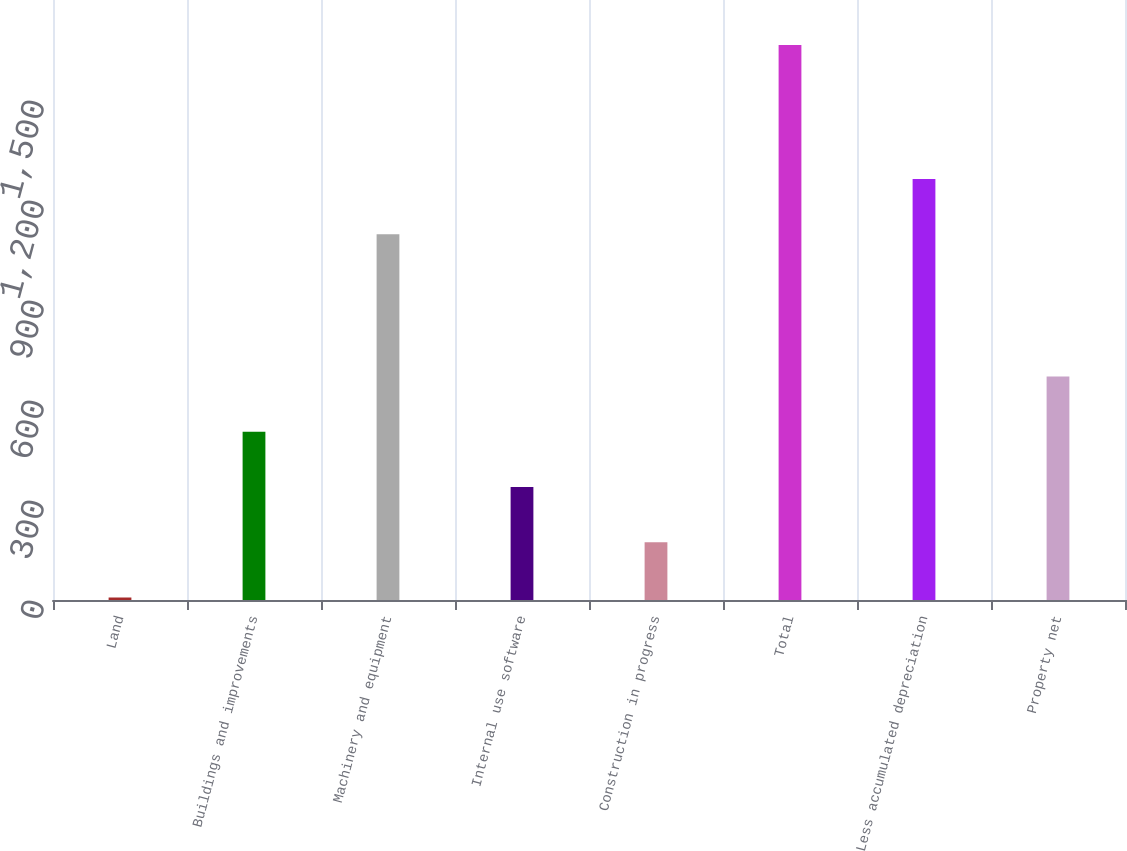Convert chart. <chart><loc_0><loc_0><loc_500><loc_500><bar_chart><fcel>Land<fcel>Buildings and improvements<fcel>Machinery and equipment<fcel>Internal use software<fcel>Construction in progress<fcel>Total<fcel>Less accumulated depreciation<fcel>Property net<nl><fcel>7.5<fcel>504.78<fcel>1097.3<fcel>339.02<fcel>173.26<fcel>1665.1<fcel>1263.06<fcel>670.54<nl></chart> 